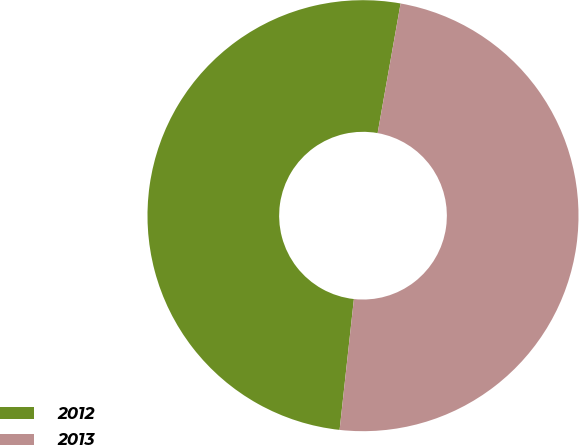Convert chart. <chart><loc_0><loc_0><loc_500><loc_500><pie_chart><fcel>2012<fcel>2013<nl><fcel>51.06%<fcel>48.94%<nl></chart> 